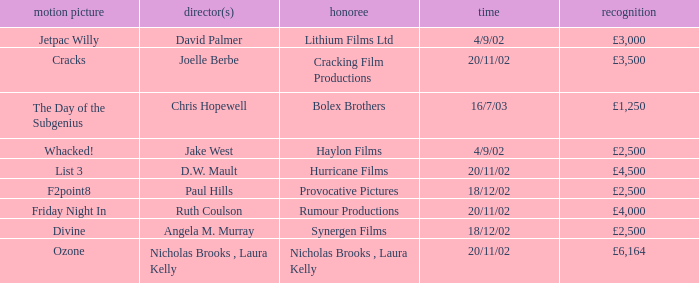What award did the film Ozone win? £6,164. 